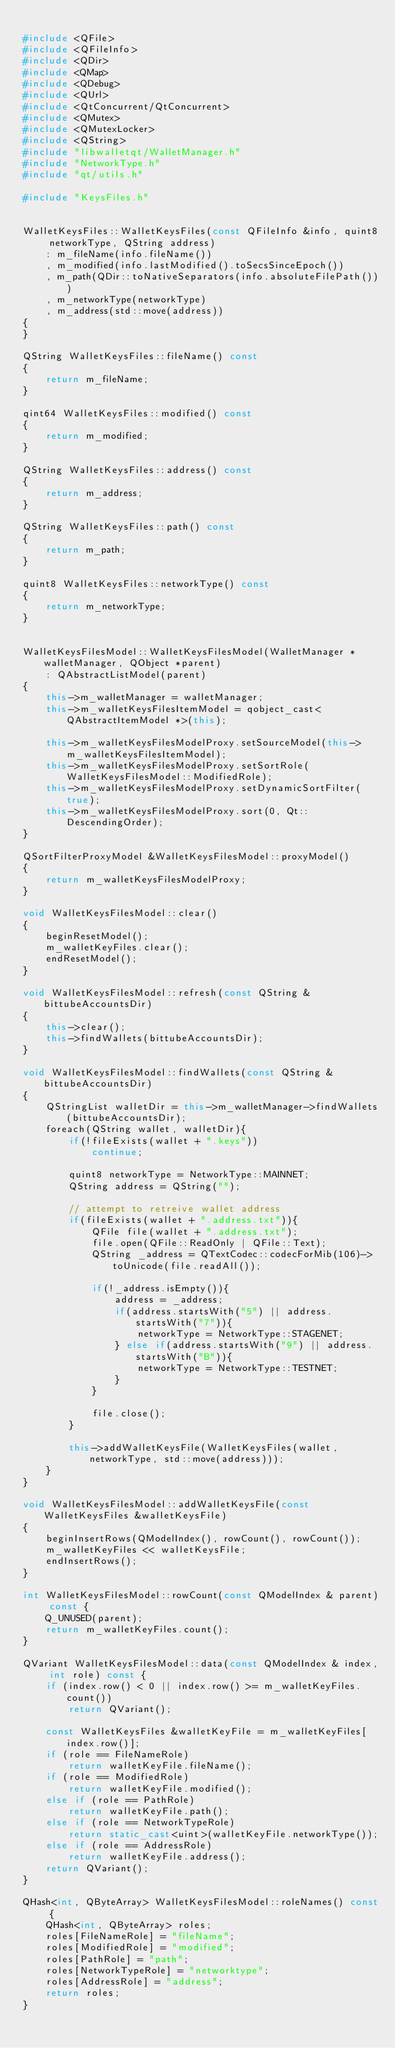Convert code to text. <code><loc_0><loc_0><loc_500><loc_500><_C++_>
#include <QFile>
#include <QFileInfo>
#include <QDir>
#include <QMap>
#include <QDebug>
#include <QUrl>
#include <QtConcurrent/QtConcurrent>
#include <QMutex>
#include <QMutexLocker>
#include <QString>
#include "libwalletqt/WalletManager.h"
#include "NetworkType.h"
#include "qt/utils.h"

#include "KeysFiles.h"


WalletKeysFiles::WalletKeysFiles(const QFileInfo &info, quint8 networkType, QString address)
    : m_fileName(info.fileName())
    , m_modified(info.lastModified().toSecsSinceEpoch())
    , m_path(QDir::toNativeSeparators(info.absoluteFilePath()))
    , m_networkType(networkType)
    , m_address(std::move(address))
{
}

QString WalletKeysFiles::fileName() const
{
    return m_fileName;
}

qint64 WalletKeysFiles::modified() const
{
    return m_modified;
}

QString WalletKeysFiles::address() const
{
    return m_address;
}

QString WalletKeysFiles::path() const
{
    return m_path;
}

quint8 WalletKeysFiles::networkType() const
{
    return m_networkType;
}


WalletKeysFilesModel::WalletKeysFilesModel(WalletManager *walletManager, QObject *parent)
    : QAbstractListModel(parent)
{
    this->m_walletManager = walletManager;
    this->m_walletKeysFilesItemModel = qobject_cast<QAbstractItemModel *>(this);

    this->m_walletKeysFilesModelProxy.setSourceModel(this->m_walletKeysFilesItemModel);
    this->m_walletKeysFilesModelProxy.setSortRole(WalletKeysFilesModel::ModifiedRole);
    this->m_walletKeysFilesModelProxy.setDynamicSortFilter(true);
    this->m_walletKeysFilesModelProxy.sort(0, Qt::DescendingOrder);
}

QSortFilterProxyModel &WalletKeysFilesModel::proxyModel()
{
    return m_walletKeysFilesModelProxy;
}

void WalletKeysFilesModel::clear()
{
    beginResetModel();
    m_walletKeyFiles.clear();
    endResetModel();
}

void WalletKeysFilesModel::refresh(const QString &bittubeAccountsDir)
{
    this->clear();
    this->findWallets(bittubeAccountsDir);
}

void WalletKeysFilesModel::findWallets(const QString &bittubeAccountsDir)
{
    QStringList walletDir = this->m_walletManager->findWallets(bittubeAccountsDir);
    foreach(QString wallet, walletDir){
        if(!fileExists(wallet + ".keys"))
            continue;

        quint8 networkType = NetworkType::MAINNET;
        QString address = QString("");

        // attempt to retreive wallet address
        if(fileExists(wallet + ".address.txt")){
            QFile file(wallet + ".address.txt");
            file.open(QFile::ReadOnly | QFile::Text);
            QString _address = QTextCodec::codecForMib(106)->toUnicode(file.readAll());

            if(!_address.isEmpty()){
                address = _address;
                if(address.startsWith("5") || address.startsWith("7")){
                    networkType = NetworkType::STAGENET;
                } else if(address.startsWith("9") || address.startsWith("B")){
                    networkType = NetworkType::TESTNET;
                }
            }

            file.close();
        }

        this->addWalletKeysFile(WalletKeysFiles(wallet, networkType, std::move(address)));
    }
}

void WalletKeysFilesModel::addWalletKeysFile(const WalletKeysFiles &walletKeysFile)
{
    beginInsertRows(QModelIndex(), rowCount(), rowCount());
    m_walletKeyFiles << walletKeysFile;
    endInsertRows();
}

int WalletKeysFilesModel::rowCount(const QModelIndex & parent) const {
    Q_UNUSED(parent);
    return m_walletKeyFiles.count();
}

QVariant WalletKeysFilesModel::data(const QModelIndex & index, int role) const {
    if (index.row() < 0 || index.row() >= m_walletKeyFiles.count())
        return QVariant();

    const WalletKeysFiles &walletKeyFile = m_walletKeyFiles[index.row()];
    if (role == FileNameRole)
        return walletKeyFile.fileName();
    if (role == ModifiedRole)
        return walletKeyFile.modified();
    else if (role == PathRole)
        return walletKeyFile.path();
    else if (role == NetworkTypeRole)
        return static_cast<uint>(walletKeyFile.networkType());
    else if (role == AddressRole)
        return walletKeyFile.address();
    return QVariant();
}

QHash<int, QByteArray> WalletKeysFilesModel::roleNames() const {
    QHash<int, QByteArray> roles;
    roles[FileNameRole] = "fileName";
    roles[ModifiedRole] = "modified";
    roles[PathRole] = "path";
    roles[NetworkTypeRole] = "networktype";
    roles[AddressRole] = "address";
    return roles;
}
</code> 